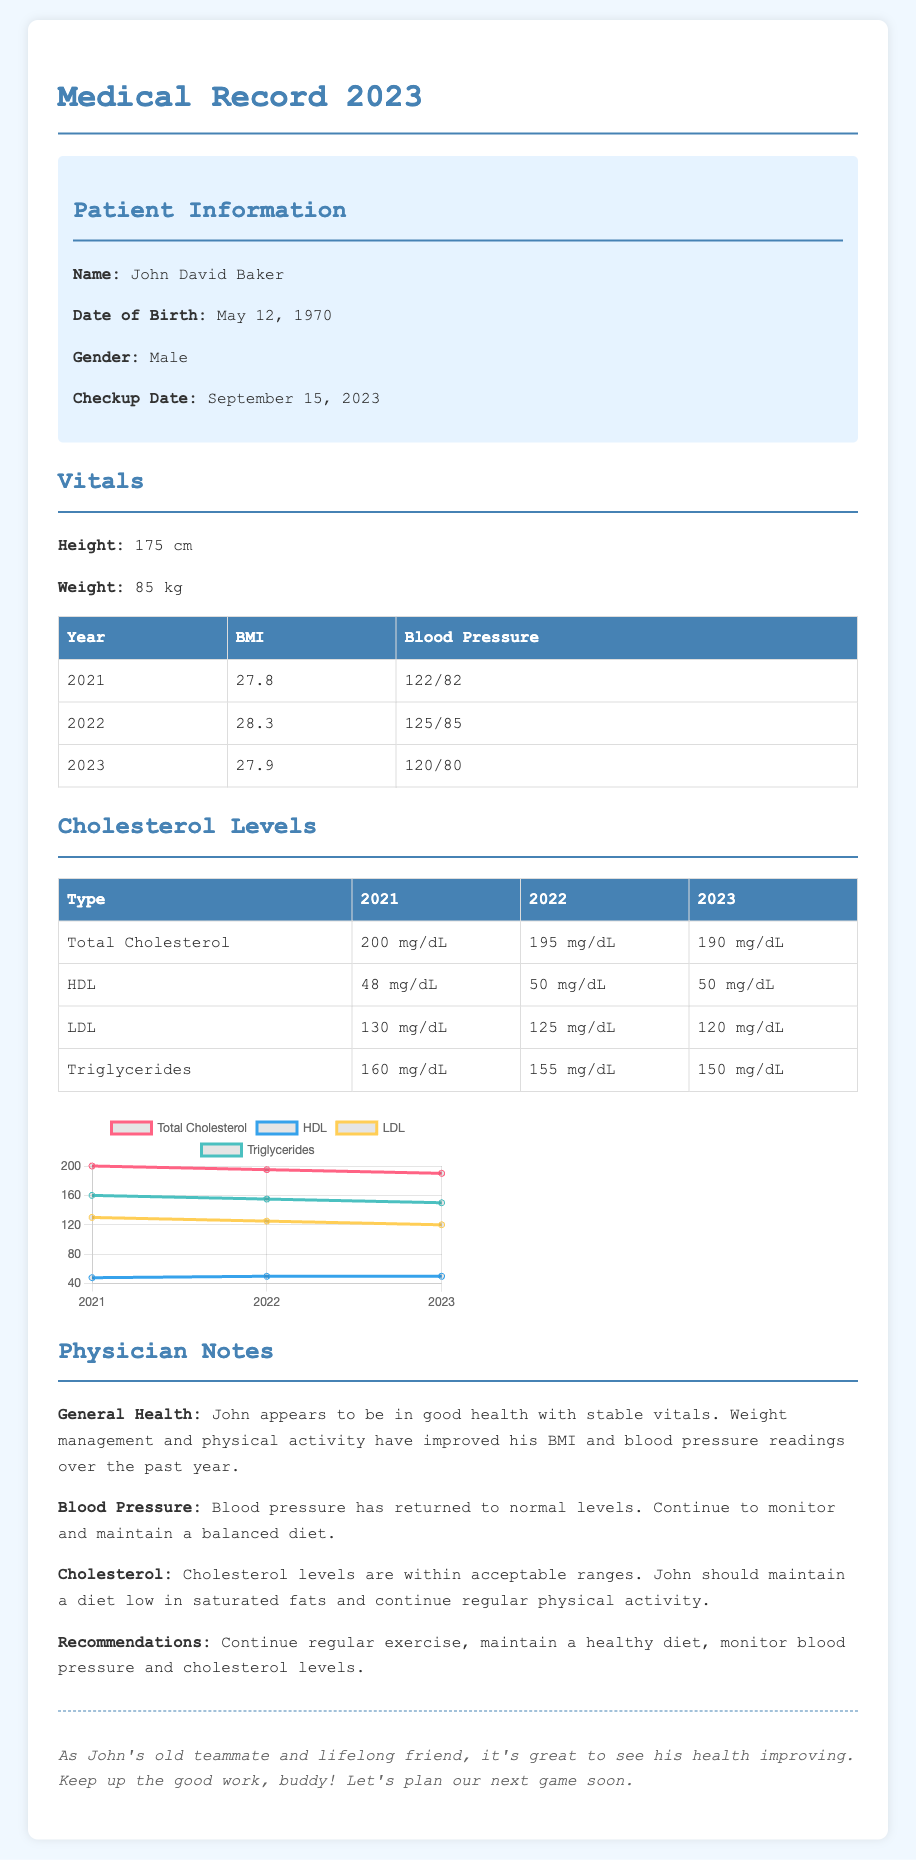what is John David Baker's date of birth? The document states John David Baker's date of birth as May 12, 1970.
Answer: May 12, 1970 what was John David Baker's BMI in 2022? The BMI for John David Baker in 2022 is provided in the table, which shows it as 28.3.
Answer: 28.3 what is John David Baker's blood pressure reading in 2023? The blood pressure for 2023 is listed in the vitals section as 120/80.
Answer: 120/80 how many years of data are provided for cholesterol levels? The document includes cholesterol level data for three years: 2021, 2022, and 2023, indicating a total of three years.
Answer: 3 years what is the trend in total cholesterol from 2021 to 2023? The total cholesterol readings from 2021 to 2023 decline from 200 mg/dL to 190 mg/dL, indicating a downward trend.
Answer: Downward trend what recommendation is given for John regarding his diet? The recommendation refers to maintaining a diet low in saturated fats as stated in the physician notes.
Answer: Low in saturated fats what has been stated about John David Baker's general health? The physician notes comment on his general health as being in good health with stable vitals.
Answer: Good health with stable vitals what was John David Baker's weight in 2023? The document indicates that John David Baker's weight in 2023 is 85 kg.
Answer: 85 kg 